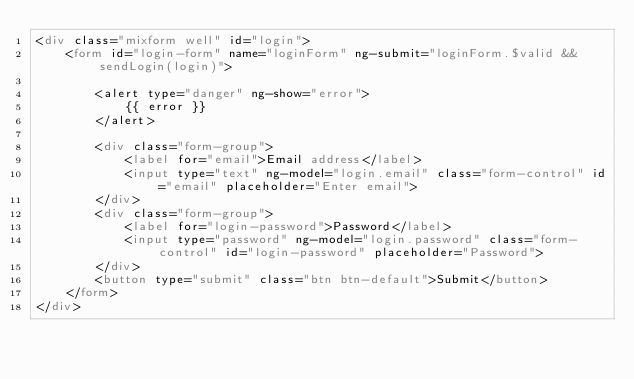Convert code to text. <code><loc_0><loc_0><loc_500><loc_500><_HTML_><div class="mixform well" id="login">
    <form id="login-form" name="loginForm" ng-submit="loginForm.$valid && sendLogin(login)">

        <alert type="danger" ng-show="error">
            {{ error }}
        </alert>

        <div class="form-group">
            <label for="email">Email address</label>
            <input type="text" ng-model="login.email" class="form-control" id="email" placeholder="Enter email">
        </div>
        <div class="form-group">
            <label for="login-password">Password</label>
            <input type="password" ng-model="login.password" class="form-control" id="login-password" placeholder="Password">
        </div>
        <button type="submit" class="btn btn-default">Submit</button>
    </form>
</div></code> 